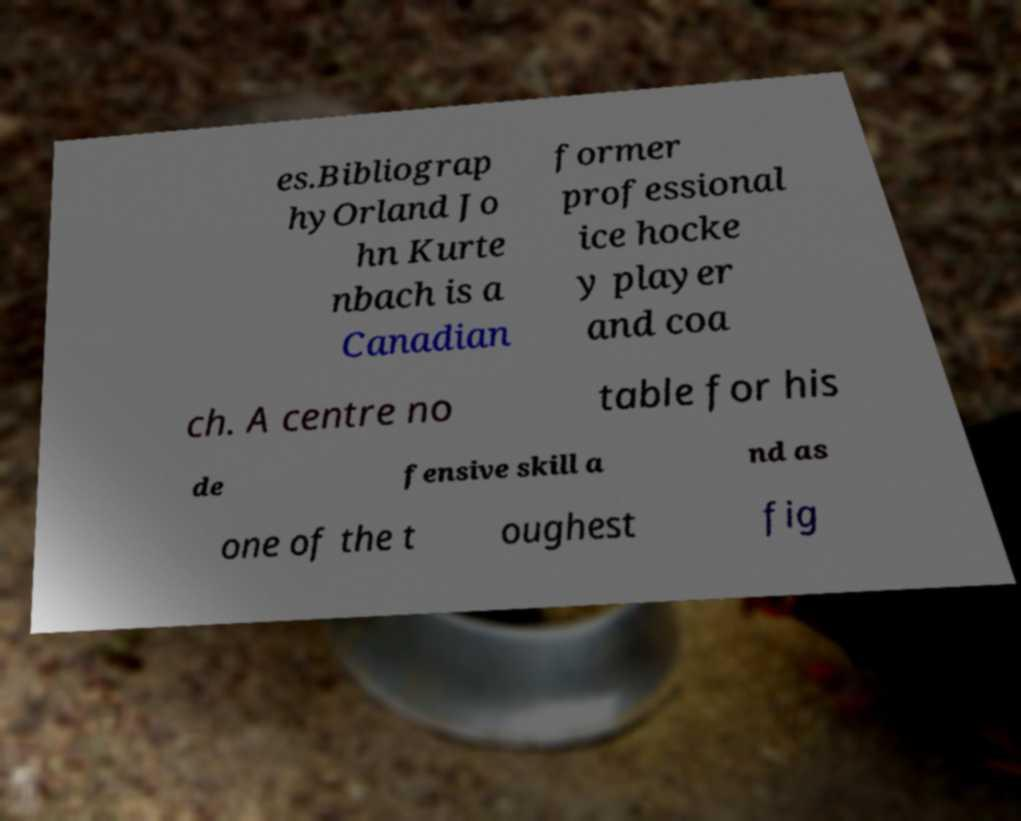Can you read and provide the text displayed in the image?This photo seems to have some interesting text. Can you extract and type it out for me? es.Bibliograp hyOrland Jo hn Kurte nbach is a Canadian former professional ice hocke y player and coa ch. A centre no table for his de fensive skill a nd as one of the t oughest fig 